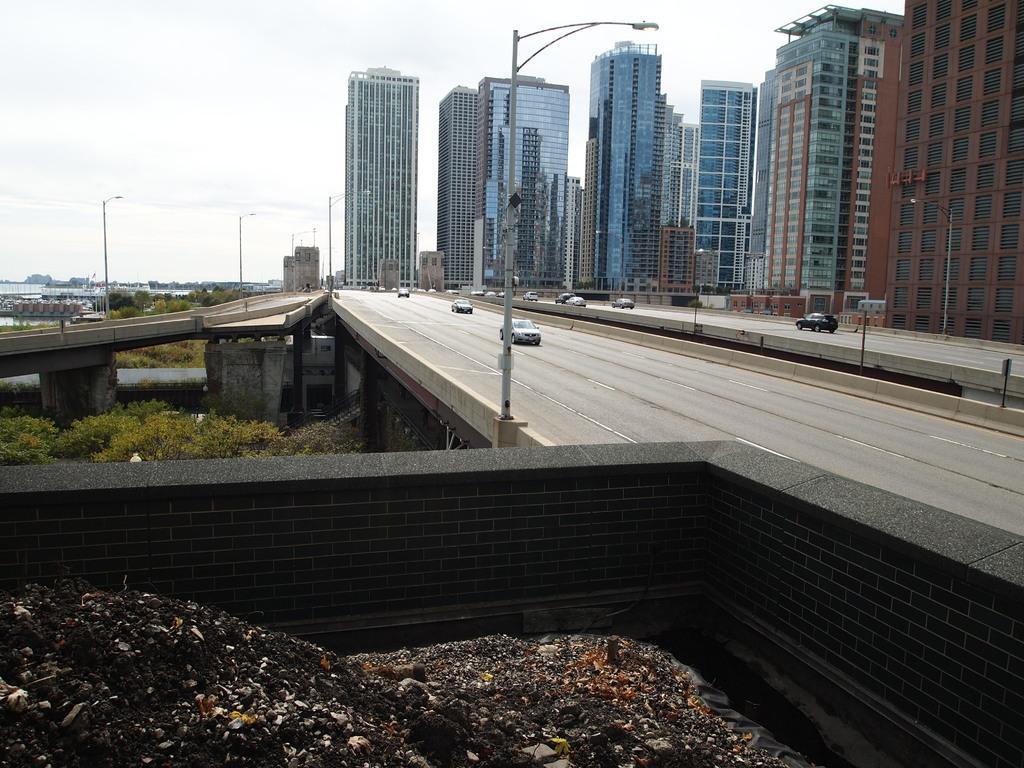How would you summarize this image in a sentence or two? This picture shows buildings and a freeway and we see vehicles moving and few pole lights and we see trees and a cloudy sky. 